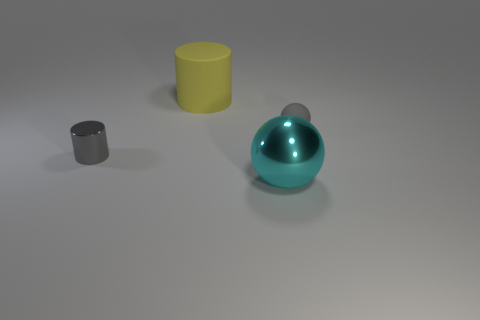What number of other objects are the same material as the gray cylinder?
Give a very brief answer. 1. What number of big objects are there?
Ensure brevity in your answer.  2. There is a small gray object that is the same shape as the yellow thing; what is its material?
Give a very brief answer. Metal. Do the cylinder that is in front of the large rubber object and the large cyan object have the same material?
Provide a short and direct response. Yes. Is the number of objects that are on the left side of the rubber cylinder greater than the number of big cylinders right of the small matte sphere?
Your response must be concise. Yes. What is the size of the cyan metal ball?
Ensure brevity in your answer.  Large. The tiny gray object that is made of the same material as the big yellow object is what shape?
Make the answer very short. Sphere. Does the big object that is in front of the small gray metal cylinder have the same shape as the tiny gray metal thing?
Your answer should be very brief. No. What number of objects are either big red metal things or big cyan metallic balls?
Provide a short and direct response. 1. What is the thing that is both in front of the small gray ball and on the right side of the big rubber cylinder made of?
Your response must be concise. Metal. 